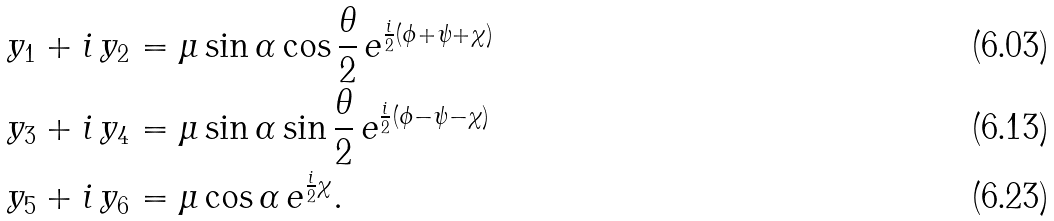<formula> <loc_0><loc_0><loc_500><loc_500>& y _ { 1 } + i \, y _ { 2 } = \mu \sin \alpha \cos \frac { \theta } { 2 } \, e ^ { \frac { i } { 2 } ( \phi + \psi + \chi ) } \\ & y _ { 3 } + i \, y _ { 4 } = \mu \sin \alpha \sin \frac { \theta } { 2 } \, e ^ { \frac { i } { 2 } ( \phi - \psi - \chi ) } \\ & y _ { 5 } + i \, y _ { 6 } = \mu \cos \alpha \, e ^ { \frac { i } { 2 } \chi } .</formula> 